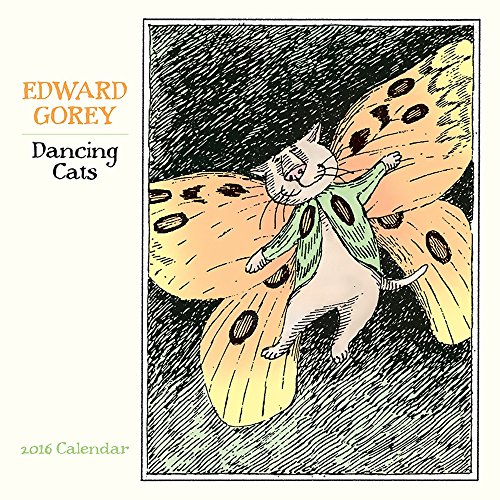Is this book related to Arts & Photography? While the primary classification of the book is calendars, due to Edward Gorey's distinctive artistic style showcased in the whimsical cat illustrations, it also holds appeal for enthusiasts of Arts & Photography. 